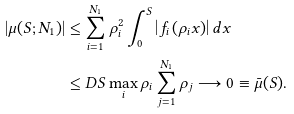<formula> <loc_0><loc_0><loc_500><loc_500>| \mu ( S ; N _ { 1 } ) | & \leq \sum _ { i = 1 } ^ { N _ { 1 } } \rho _ { i } ^ { 2 } \int _ { 0 } ^ { S } \left | f _ { i } \left ( { \rho _ { i } } x \right ) \right | d x \\ & \leq D S \max _ { i } \rho _ { i } \sum _ { j = 1 } ^ { N _ { 1 } } \rho _ { j } \longrightarrow 0 \equiv \bar { \mu } ( S ) .</formula> 